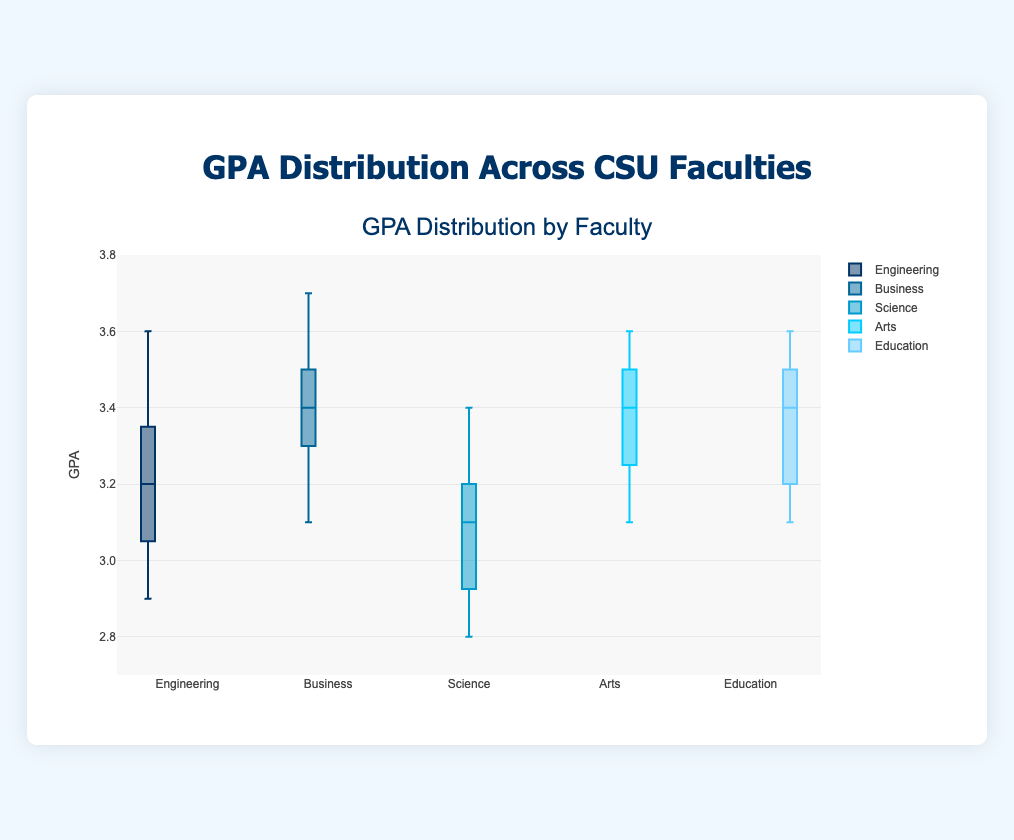What is the title of the box plot? Look at the text displayed prominently at the top of the plot. The title describes what the plot is about.
Answer: GPA Distribution by Faculty Which faculty has the highest median GPA? Compare the median lines (the lines inside the boxes) of each faculty's box plot. The one with the highest position on the y-axis has the highest median GPA.
Answer: Business What is the GPA range for Engineering faculty? Examine the length of the box and the whiskers for Engineering. The box represents the interquartile range, and the whiskers show the overall range of the data.
Answer: 2.9 to 3.6 Which two faculties have the closest median GPA values? Look at the median lines within the boxes for each faculty. Compare the medians to find the two that are closest to each other in value.
Answer: Education and Arts How do the interquartile ranges (IQR) of Science and Business compare? Compare the size of the boxes for Science and Business. The IQR is the range between the first quartile (bottom of the box) and the third quartile (top of the box).
Answer: Business has a smaller IQR than Science Which faculty has the most outliers? Check the number of 'suspected outliers' marked by individual points outside the whiskers for each faculty. The one with the most marks has the most outliers.
Answer: Science What is the median GPA for Engineering faculty? Look at the line inside the box plot for Engineering that represents the median value. Read the value off the y-axis.
Answer: 3.2 How does the spread of GPA values for Arts compare to Engineering? Compare the lengths of the boxes and whiskers for Arts and Engineering. A longer box and whiskers indicate a wider spread of values.
Answer: Engineering has a wider spread What is the approximate range of the top 25% of GPAs in the Business faculty? The top 25% of GPAs are in the third quartile, indicated by the top part of the box. Examine the height of this segment.
Answer: 3.5 to 3.7 